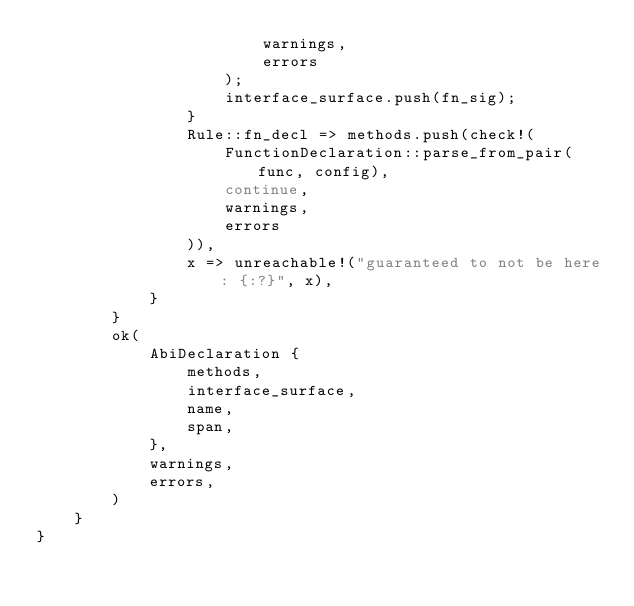Convert code to text. <code><loc_0><loc_0><loc_500><loc_500><_Rust_>                        warnings,
                        errors
                    );
                    interface_surface.push(fn_sig);
                }
                Rule::fn_decl => methods.push(check!(
                    FunctionDeclaration::parse_from_pair(func, config),
                    continue,
                    warnings,
                    errors
                )),
                x => unreachable!("guaranteed to not be here: {:?}", x),
            }
        }
        ok(
            AbiDeclaration {
                methods,
                interface_surface,
                name,
                span,
            },
            warnings,
            errors,
        )
    }
}
</code> 